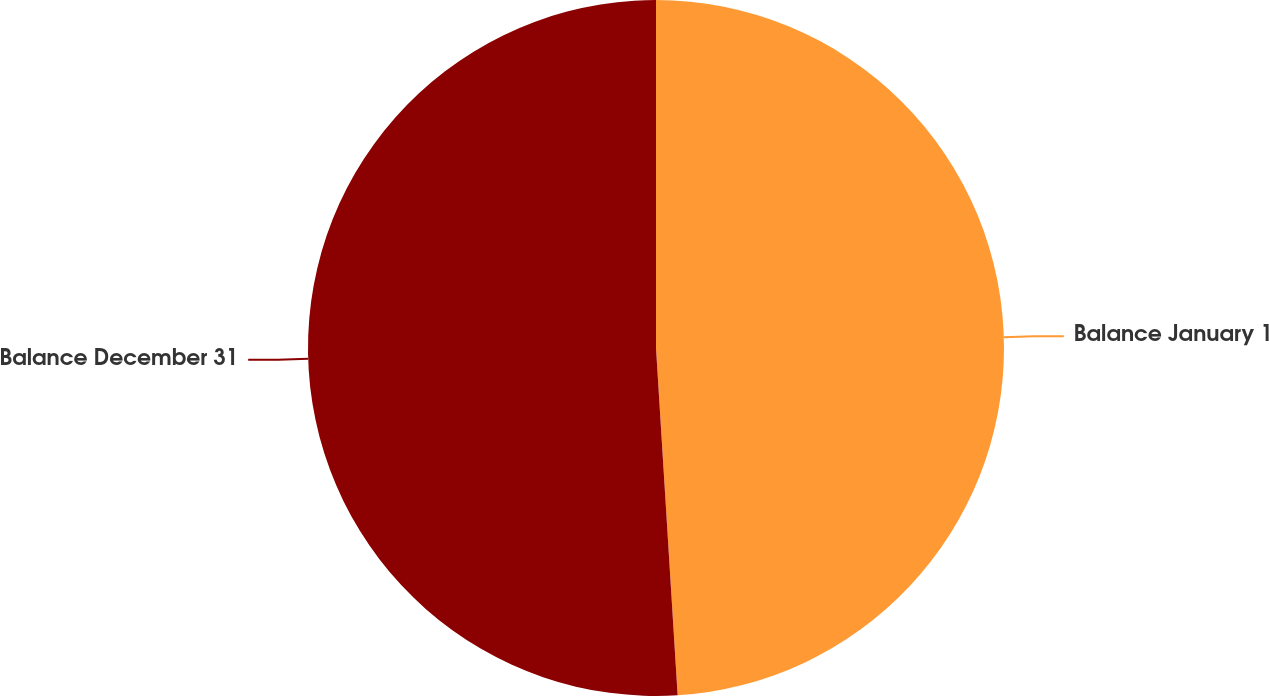<chart> <loc_0><loc_0><loc_500><loc_500><pie_chart><fcel>Balance January 1<fcel>Balance December 31<nl><fcel>49.01%<fcel>50.99%<nl></chart> 